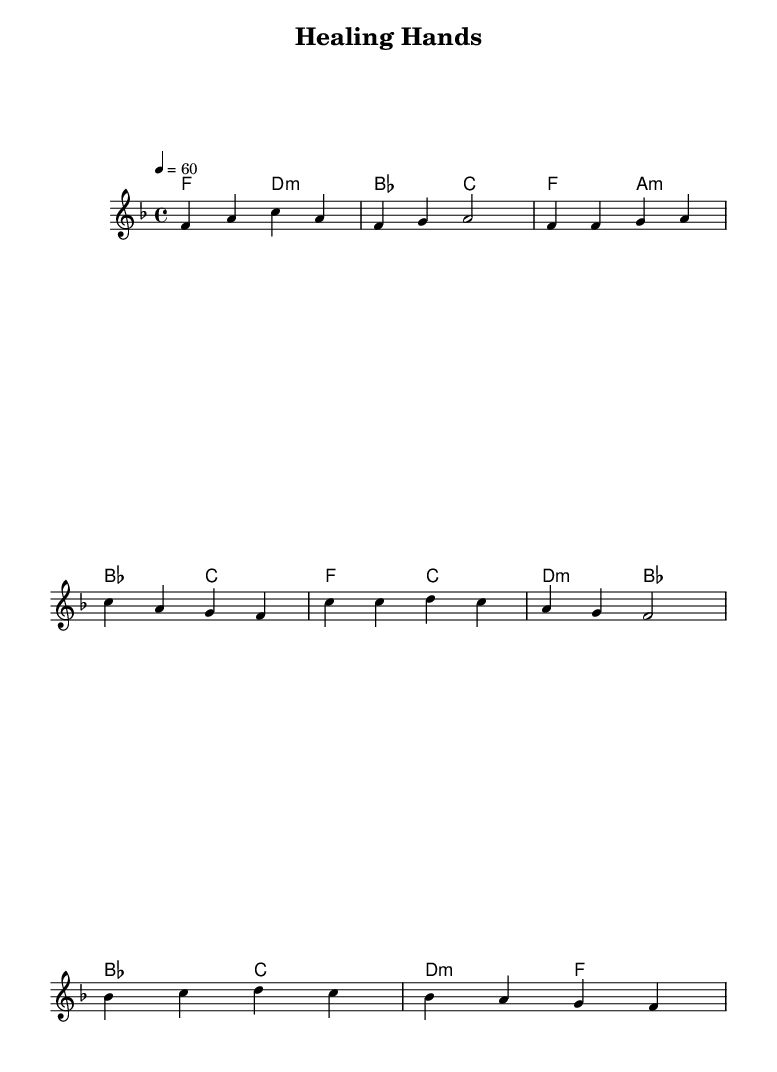What is the key signature of this music? The key signature is F major, which has one flat (B flat).
Answer: F major What is the time signature of this music? The time signature is 4/4, meaning there are four beats per measure.
Answer: 4/4 What is the tempo marking of this music? The tempo marking indicates a speed of 60 beats per minute, which is a slow tempo suitable for a ballad.
Answer: 60 How many measures are in the intro section? The intro section contains two measures of music. You can count the measures from the beginning notated within double bar lines.
Answer: 2 Which chord precedes the chorus in the chord progression? The chord that precedes the chorus is F major, found in the harmony right before the chorus starts.
Answer: F What is the emotional tone of the bridge compared to the verse? The emotional tone of the bridge tends to be reflective, moving to a transition with a rise in tension, different from the more grounded tone of the verse.
Answer: Reflective Which instruments are likely featured in a Rhythm and Blues arrangement of this piece? Instruments typically featured would include piano, guitar, bass, and possibly horns, aligning with general characteristics of Rhythm and Blues music styles.
Answer: Piano, guitar, bass, horns 